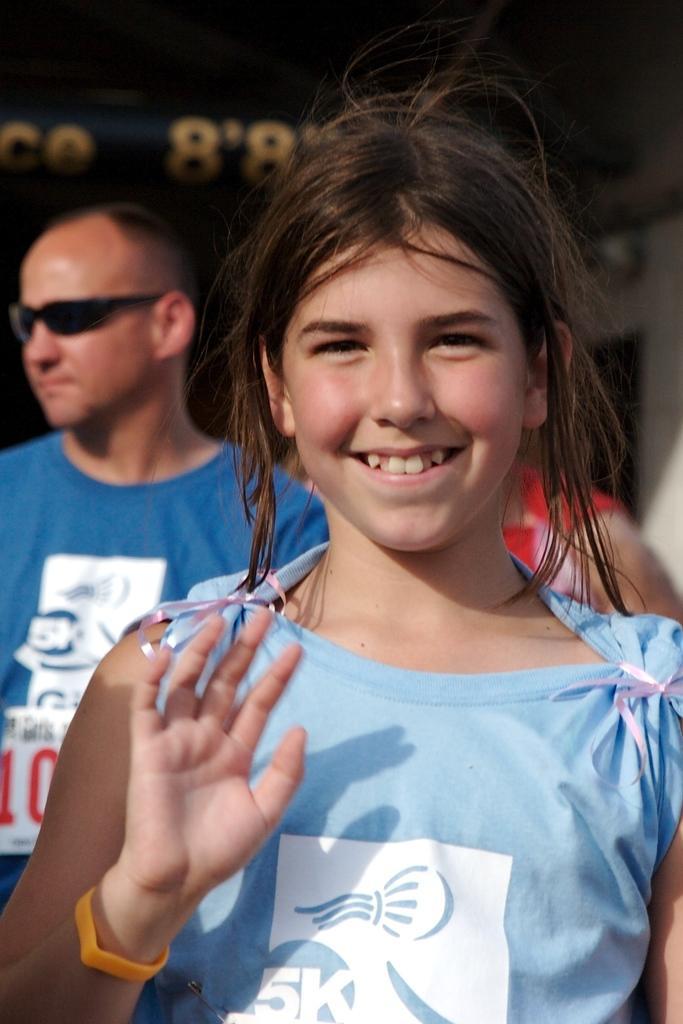Can you describe this image briefly? In this image I can see a girl standing and smiling. There are other people at the back and a person is wearing goggles. 